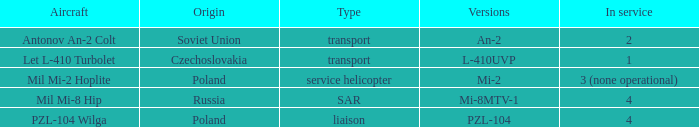Tell me the aircraft for pzl-104 PZL-104 Wilga. 